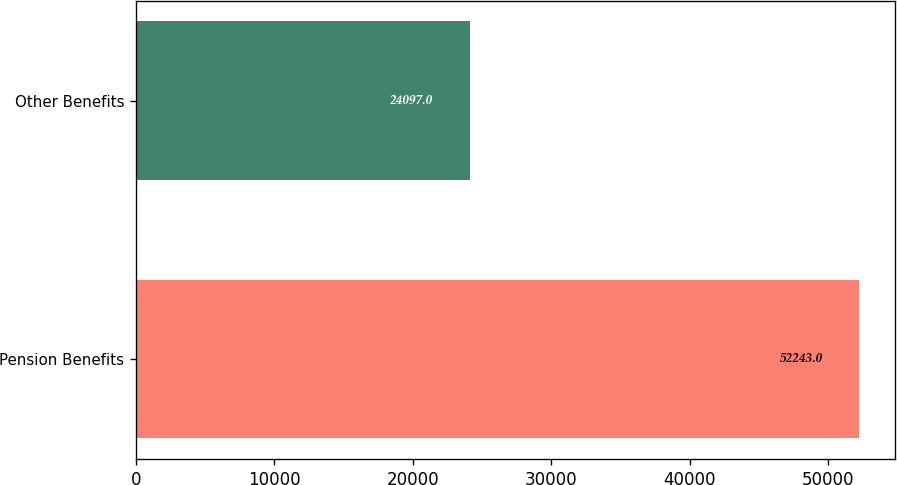<chart> <loc_0><loc_0><loc_500><loc_500><bar_chart><fcel>Pension Benefits<fcel>Other Benefits<nl><fcel>52243<fcel>24097<nl></chart> 